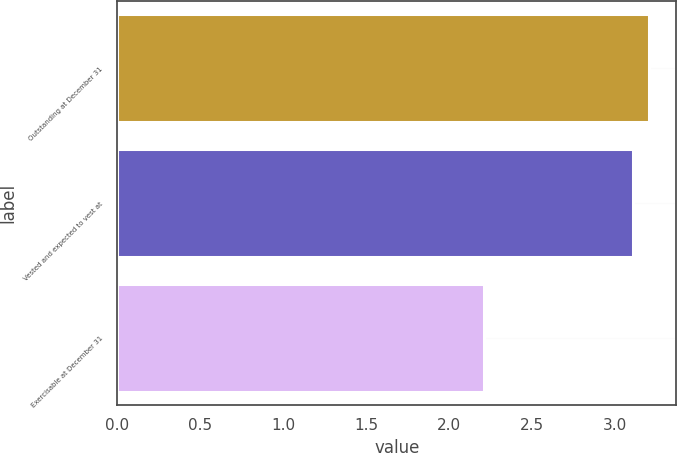<chart> <loc_0><loc_0><loc_500><loc_500><bar_chart><fcel>Outstanding at December 31<fcel>Vested and expected to vest at<fcel>Exercisable at December 31<nl><fcel>3.21<fcel>3.11<fcel>2.21<nl></chart> 